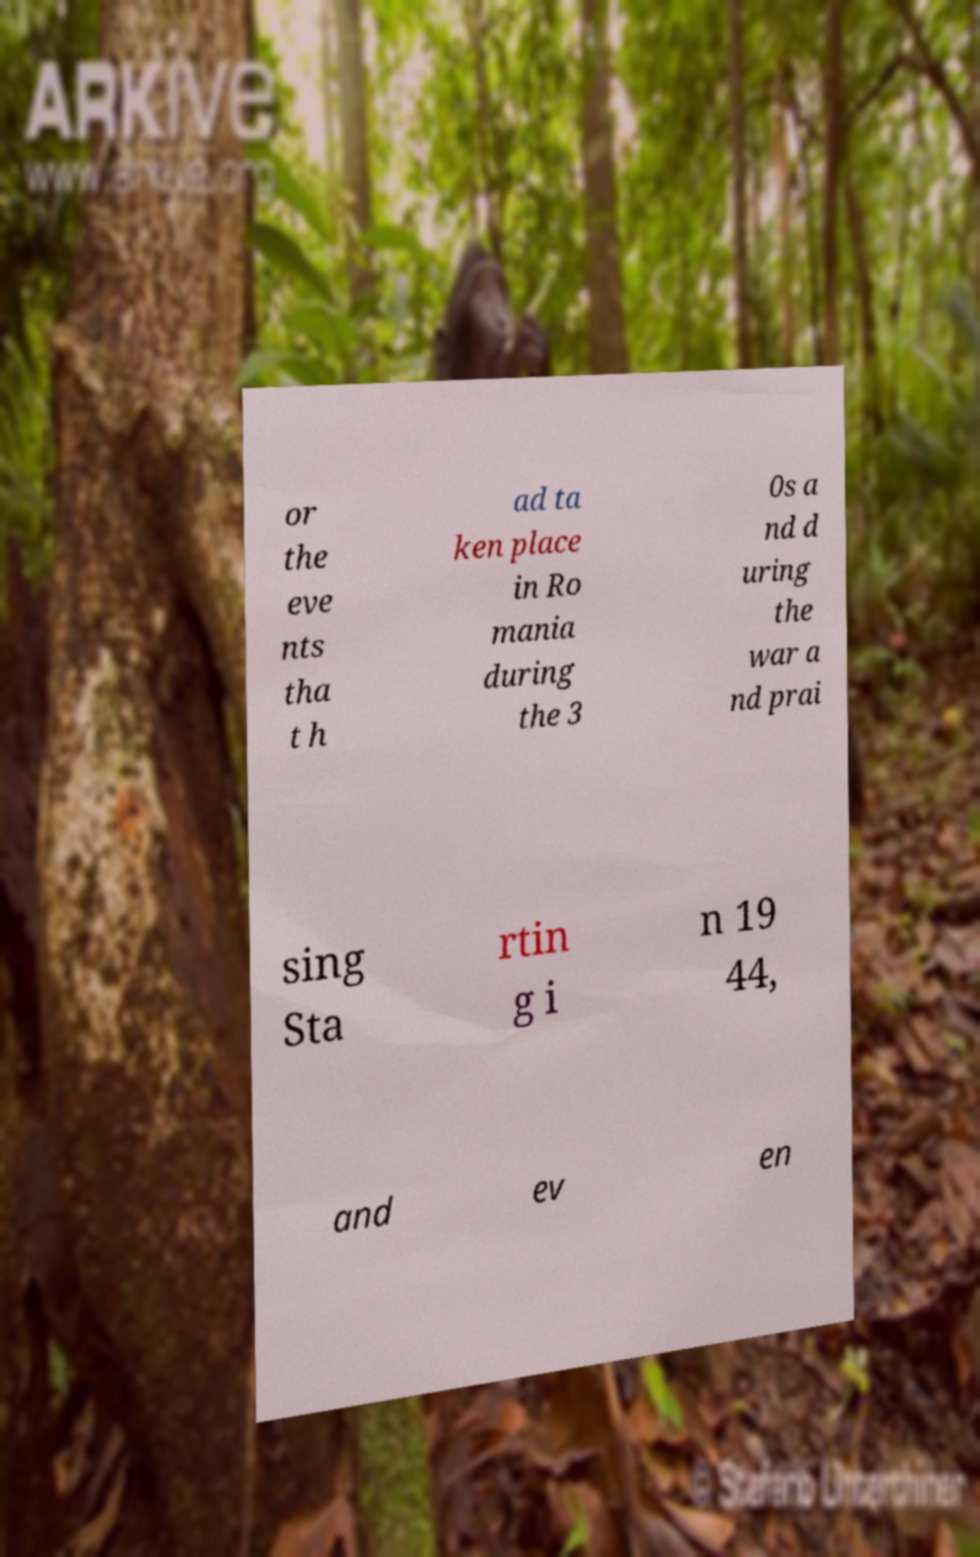Can you accurately transcribe the text from the provided image for me? or the eve nts tha t h ad ta ken place in Ro mania during the 3 0s a nd d uring the war a nd prai sing Sta rtin g i n 19 44, and ev en 